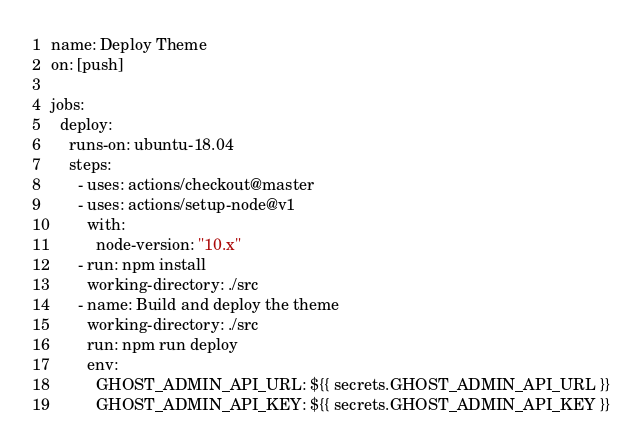Convert code to text. <code><loc_0><loc_0><loc_500><loc_500><_YAML_>name: Deploy Theme
on: [push]

jobs:
  deploy:
    runs-on: ubuntu-18.04
    steps:
      - uses: actions/checkout@master
      - uses: actions/setup-node@v1
        with:
          node-version: "10.x"
      - run: npm install
        working-directory: ./src
      - name: Build and deploy the theme
        working-directory: ./src
        run: npm run deploy
        env:
          GHOST_ADMIN_API_URL: ${{ secrets.GHOST_ADMIN_API_URL }}
          GHOST_ADMIN_API_KEY: ${{ secrets.GHOST_ADMIN_API_KEY }}
</code> 